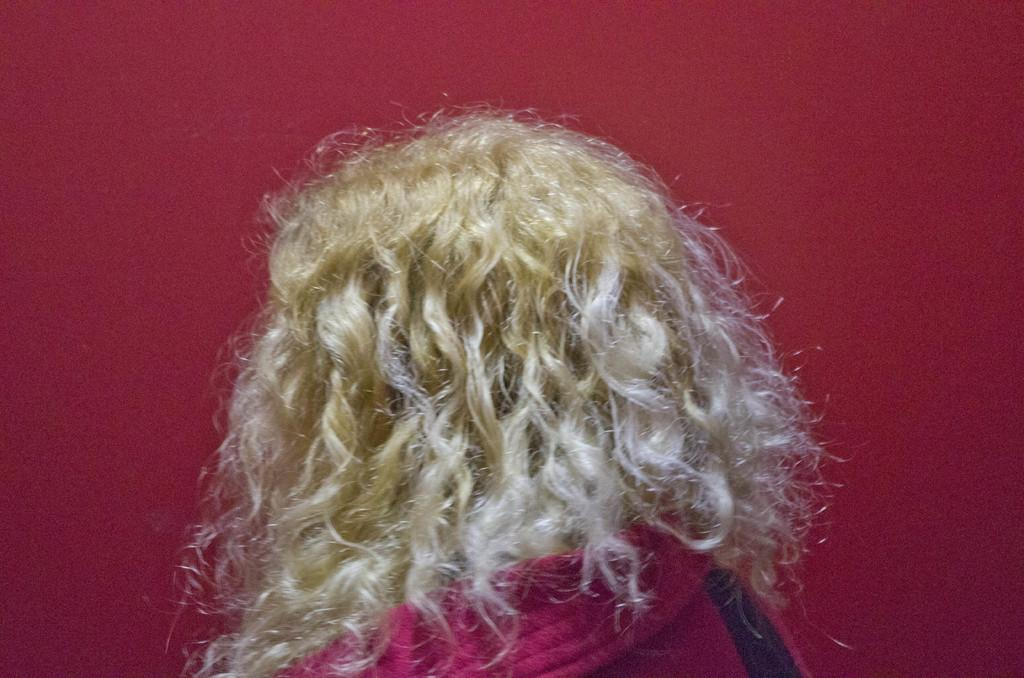Who or what is the main subject of the image? There is a person in the image. What color are the clothes the person is wearing? The person is wearing red clothes. What can be seen in the background of the image? There is a red wall in the background of the image. What type of leaf is the person holding in the image? There is no leaf present in the image; the person is wearing red clothes and standing in front of a red wall. 